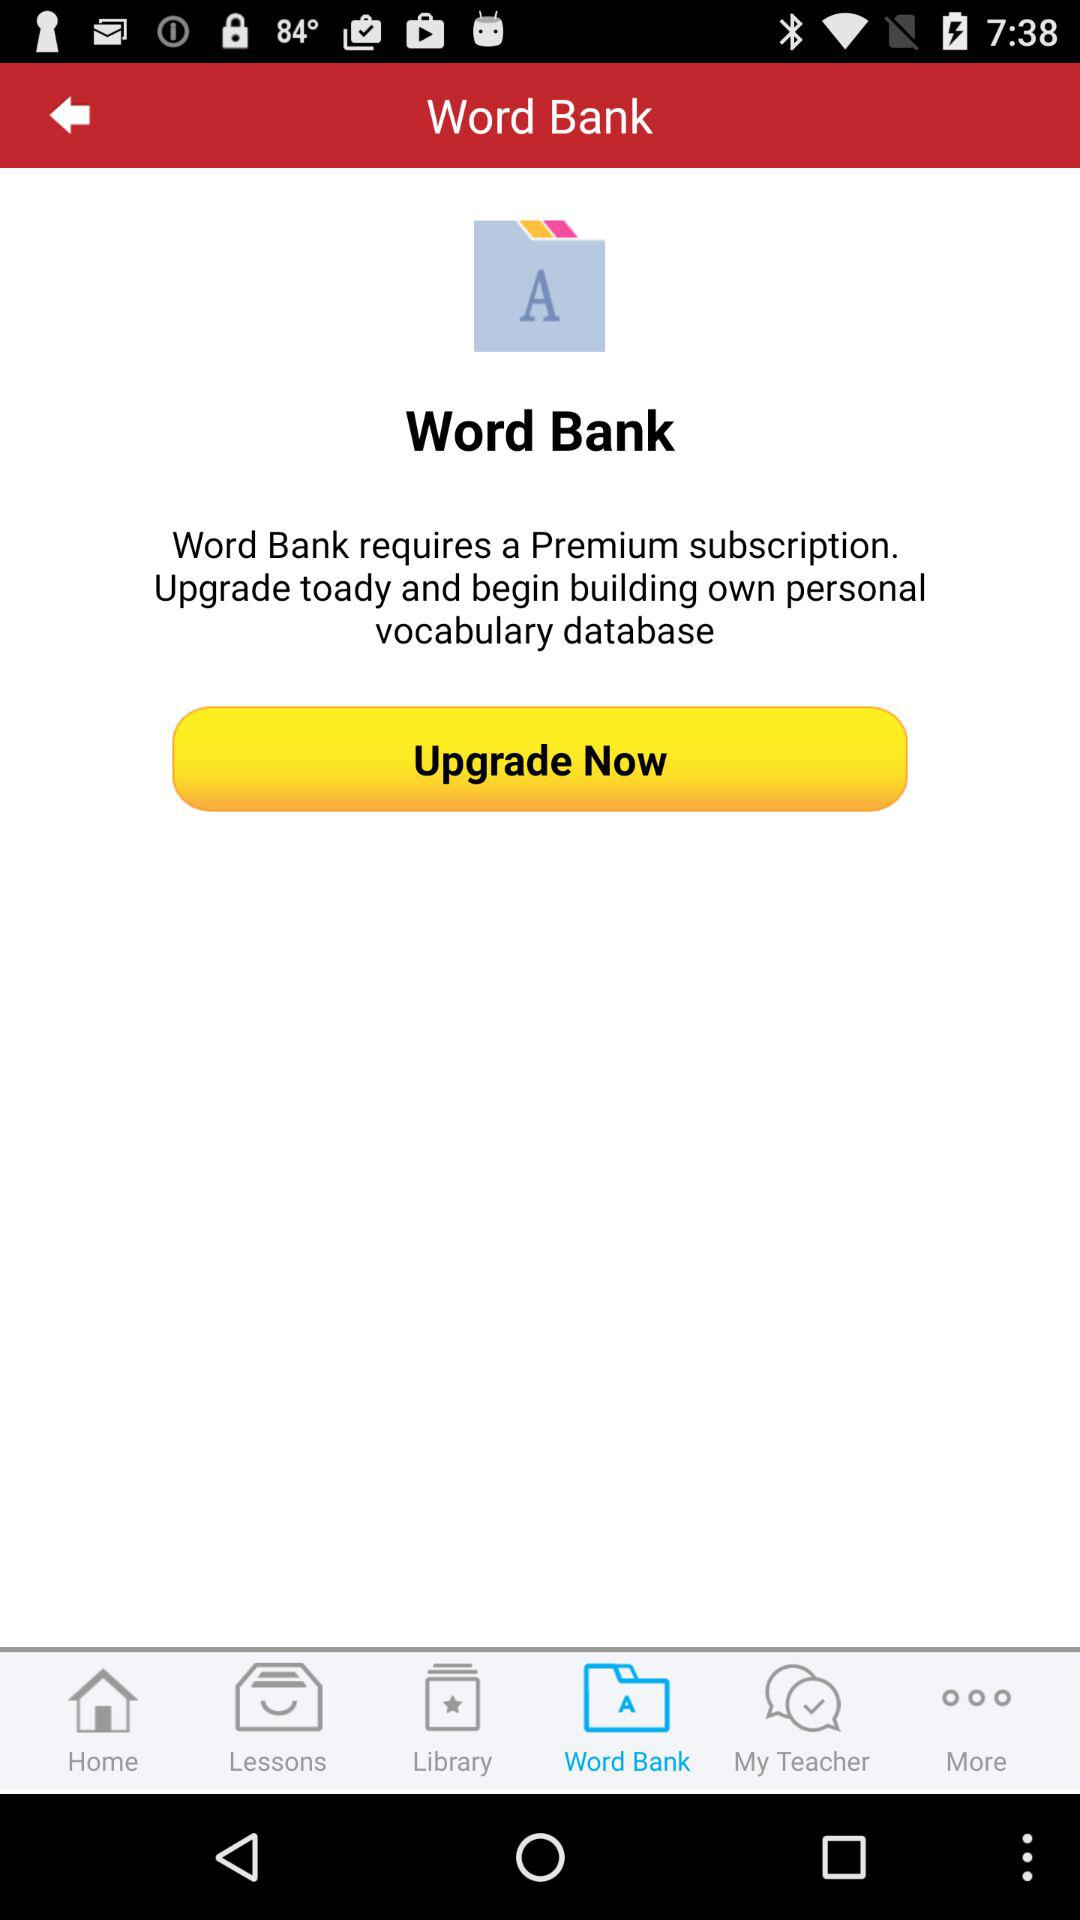What is the application name? The application name is "Word Bank". 